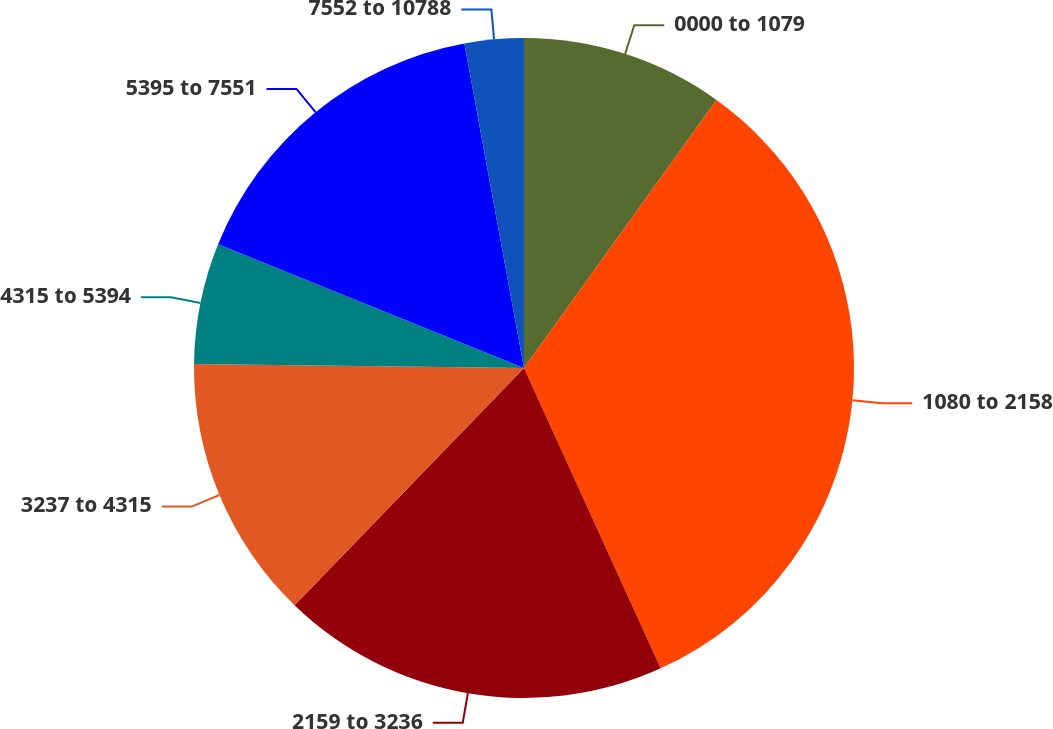Convert chart. <chart><loc_0><loc_0><loc_500><loc_500><pie_chart><fcel>0000 to 1079<fcel>1080 to 2158<fcel>2159 to 3236<fcel>3237 to 4315<fcel>4315 to 5394<fcel>5395 to 7551<fcel>7552 to 10788<nl><fcel>9.91%<fcel>33.29%<fcel>19.03%<fcel>12.95%<fcel>5.93%<fcel>15.99%<fcel>2.89%<nl></chart> 